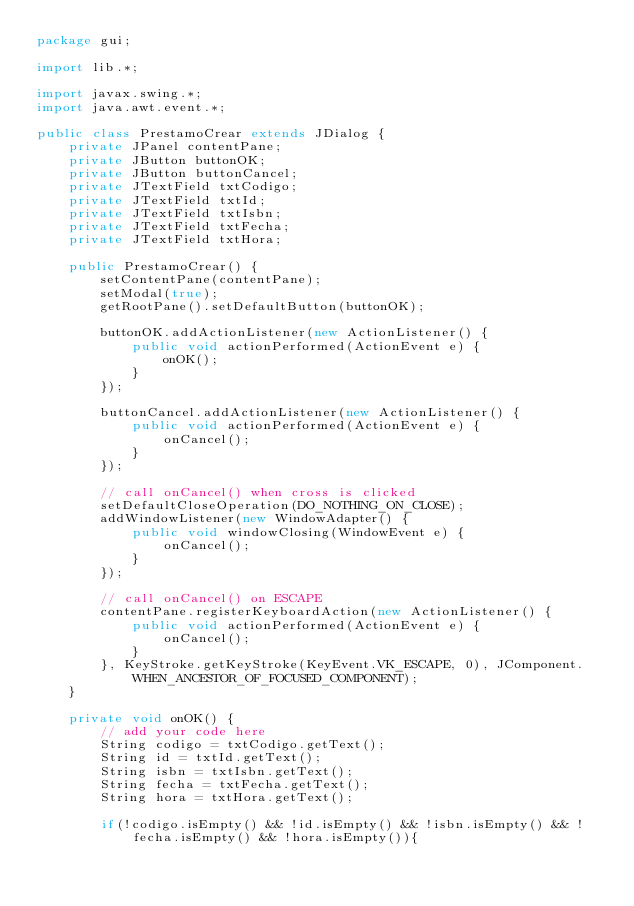Convert code to text. <code><loc_0><loc_0><loc_500><loc_500><_Java_>package gui;

import lib.*;

import javax.swing.*;
import java.awt.event.*;

public class PrestamoCrear extends JDialog {
    private JPanel contentPane;
    private JButton buttonOK;
    private JButton buttonCancel;
    private JTextField txtCodigo;
    private JTextField txtId;
    private JTextField txtIsbn;
    private JTextField txtFecha;
    private JTextField txtHora;

    public PrestamoCrear() {
        setContentPane(contentPane);
        setModal(true);
        getRootPane().setDefaultButton(buttonOK);

        buttonOK.addActionListener(new ActionListener() {
            public void actionPerformed(ActionEvent e) {
                onOK();
            }
        });

        buttonCancel.addActionListener(new ActionListener() {
            public void actionPerformed(ActionEvent e) {
                onCancel();
            }
        });

        // call onCancel() when cross is clicked
        setDefaultCloseOperation(DO_NOTHING_ON_CLOSE);
        addWindowListener(new WindowAdapter() {
            public void windowClosing(WindowEvent e) {
                onCancel();
            }
        });

        // call onCancel() on ESCAPE
        contentPane.registerKeyboardAction(new ActionListener() {
            public void actionPerformed(ActionEvent e) {
                onCancel();
            }
        }, KeyStroke.getKeyStroke(KeyEvent.VK_ESCAPE, 0), JComponent.WHEN_ANCESTOR_OF_FOCUSED_COMPONENT);
    }

    private void onOK() {
        // add your code here
        String codigo = txtCodigo.getText();
        String id = txtId.getText();
        String isbn = txtIsbn.getText();
        String fecha = txtFecha.getText();
        String hora = txtHora.getText();

        if(!codigo.isEmpty() && !id.isEmpty() && !isbn.isEmpty() && !fecha.isEmpty() && !hora.isEmpty()){</code> 